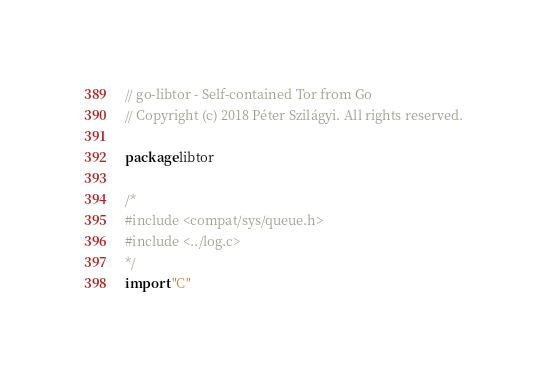<code> <loc_0><loc_0><loc_500><loc_500><_Go_>// go-libtor - Self-contained Tor from Go
// Copyright (c) 2018 Péter Szilágyi. All rights reserved.

package libtor

/*
#include <compat/sys/queue.h>
#include <../log.c>
*/
import "C"
</code> 